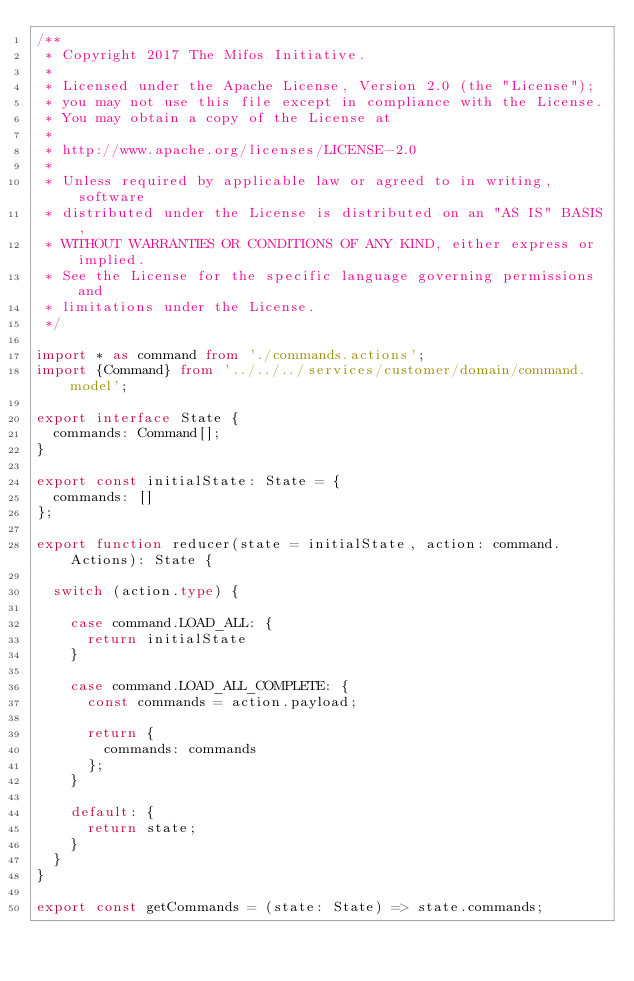Convert code to text. <code><loc_0><loc_0><loc_500><loc_500><_TypeScript_>/**
 * Copyright 2017 The Mifos Initiative.
 *
 * Licensed under the Apache License, Version 2.0 (the "License");
 * you may not use this file except in compliance with the License.
 * You may obtain a copy of the License at
 *
 * http://www.apache.org/licenses/LICENSE-2.0
 *
 * Unless required by applicable law or agreed to in writing, software
 * distributed under the License is distributed on an "AS IS" BASIS,
 * WITHOUT WARRANTIES OR CONDITIONS OF ANY KIND, either express or implied.
 * See the License for the specific language governing permissions and
 * limitations under the License.
 */

import * as command from './commands.actions';
import {Command} from '../../../services/customer/domain/command.model';

export interface State {
  commands: Command[];
}

export const initialState: State = {
  commands: []
};

export function reducer(state = initialState, action: command.Actions): State {

  switch (action.type) {

    case command.LOAD_ALL: {
      return initialState
    }

    case command.LOAD_ALL_COMPLETE: {
      const commands = action.payload;

      return {
        commands: commands
      };
    }

    default: {
      return state;
    }
  }
}

export const getCommands = (state: State) => state.commands;
</code> 